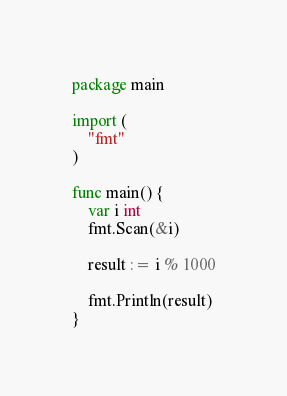<code> <loc_0><loc_0><loc_500><loc_500><_Go_>package main

import (
	"fmt"
)

func main() {
	var i int
	fmt.Scan(&i)

	result := i % 1000

	fmt.Println(result)
}</code> 